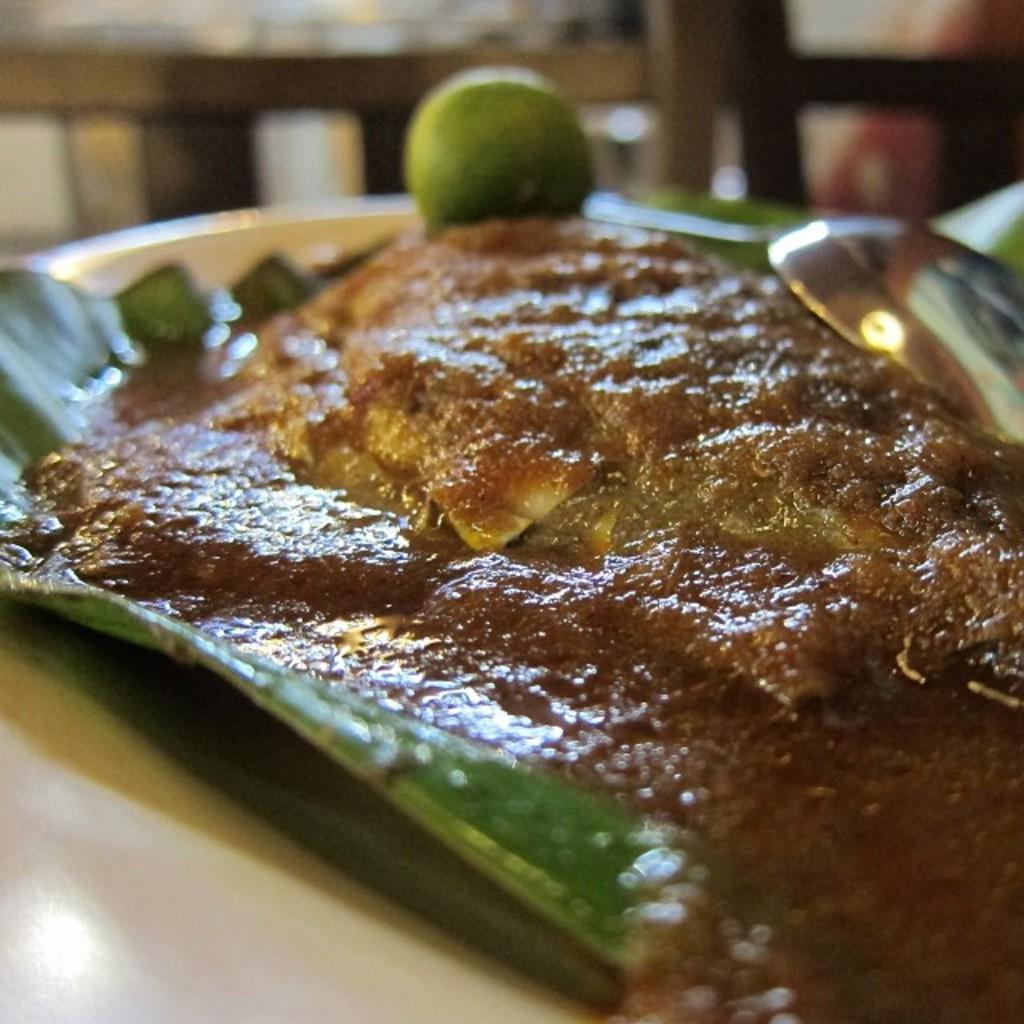What is the main subject of the image? There is a food item in the image. How is the food item presented? The food item is on a plate. What utensil is visible in the image? There is a spoon in the image. What type of produce is growing in the image? There is no produce present in the image; it features a food item on a plate with a spoon. What role does the father play in the image? There is no father present in the image, as it only shows a food item, a plate, and a spoon. 